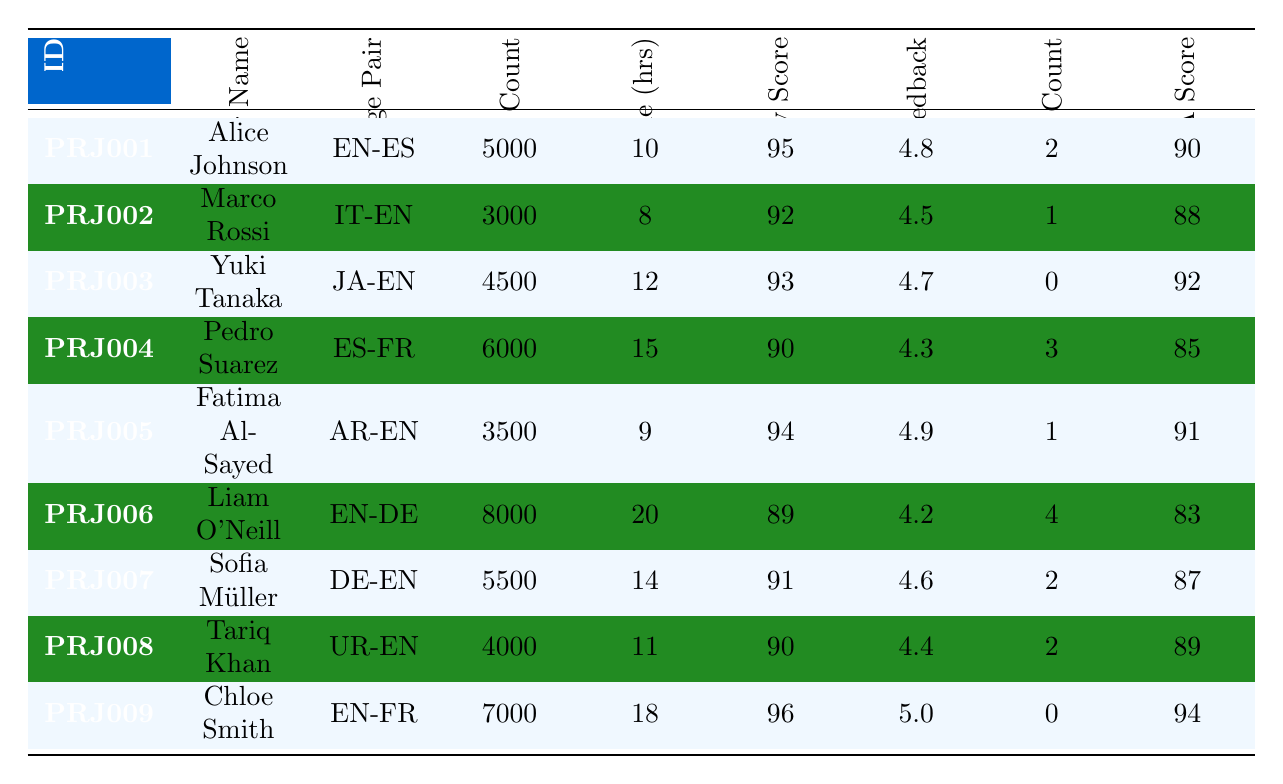What is the accuracy score of Chloe Smith's project? Chloe Smith's project is listed under project ID PRJ009 in the table. The accuracy score corresponding to this project can be found in the "Accuracy Score" column, which shows a value of 96.
Answer: 96 What is the total word count for all projects handled by Marco Rossi? Marco Rossi handled only one project, identified as PRJ002. The word count for this project is 3000, which is the only value to consider.
Answer: 3000 Is Fatima Al-Sayed's client feedback rating higher than Pedro Suarez's? Fatima Al-Sayed has a client feedback rating of 4.9, while Pedro Suarez has a rating of 4.3. Since 4.9 is higher than 4.3, the statement is true.
Answer: Yes What is the average completion time (in hours) for all the translators in this table? To calculate the average completion time, add all completion times: 10 + 8 + 12 + 15 + 9 + 20 + 14 + 11 + 18 = 127 hours. There are 9 projects so, the average time is 127/9 ≈ 14.11 hours.
Answer: Approximately 14.11 How many revision counts did translators have on average? To find the average revision count, first sum all the revision counts: 2 + 1 + 0 + 3 + 1 + 4 + 2 + 2 + 0 = 15. Divide this total by 9 (the number of projects): 15/9 ≈ 1.67.
Answer: Approximately 1.67 Did any translator complete their project without needing revisions? The table shows that Yuki Tanaka, with project ID PRJ003, has a revision count of 0, indicating they completed their project without any revisions.
Answer: Yes Which translator had the highest client feedback rating? By examining the "Client Feedback" column, Chloe Smith has the highest rating of 5.0 among all the translators, indicating she received the best feedback.
Answer: Chloe Smith What is the difference in accuracy scores between Liam O'Neill and Sofia Müller? Liam O'Neill has an accuracy score of 89 and Sofia Müller has 91. The difference can be calculated as 91 - 89 = 2.
Answer: 2 Which language pair had the least word count, and what was it? The project handled by Marco Rossi features the IT-EN language pair, which has the least word count of 3000 when compared to all other projects.
Answer: IT-EN, 3000 